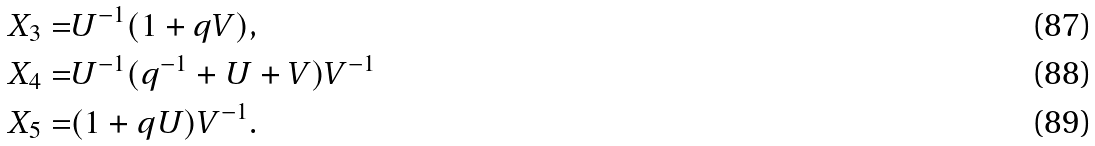Convert formula to latex. <formula><loc_0><loc_0><loc_500><loc_500>X _ { 3 } = & U ^ { - 1 } ( 1 + q V ) , \\ X _ { 4 } = & U ^ { - 1 } ( q ^ { - 1 } + U + V ) V ^ { - 1 } \\ X _ { 5 } = & ( 1 + q U ) V ^ { - 1 } .</formula> 